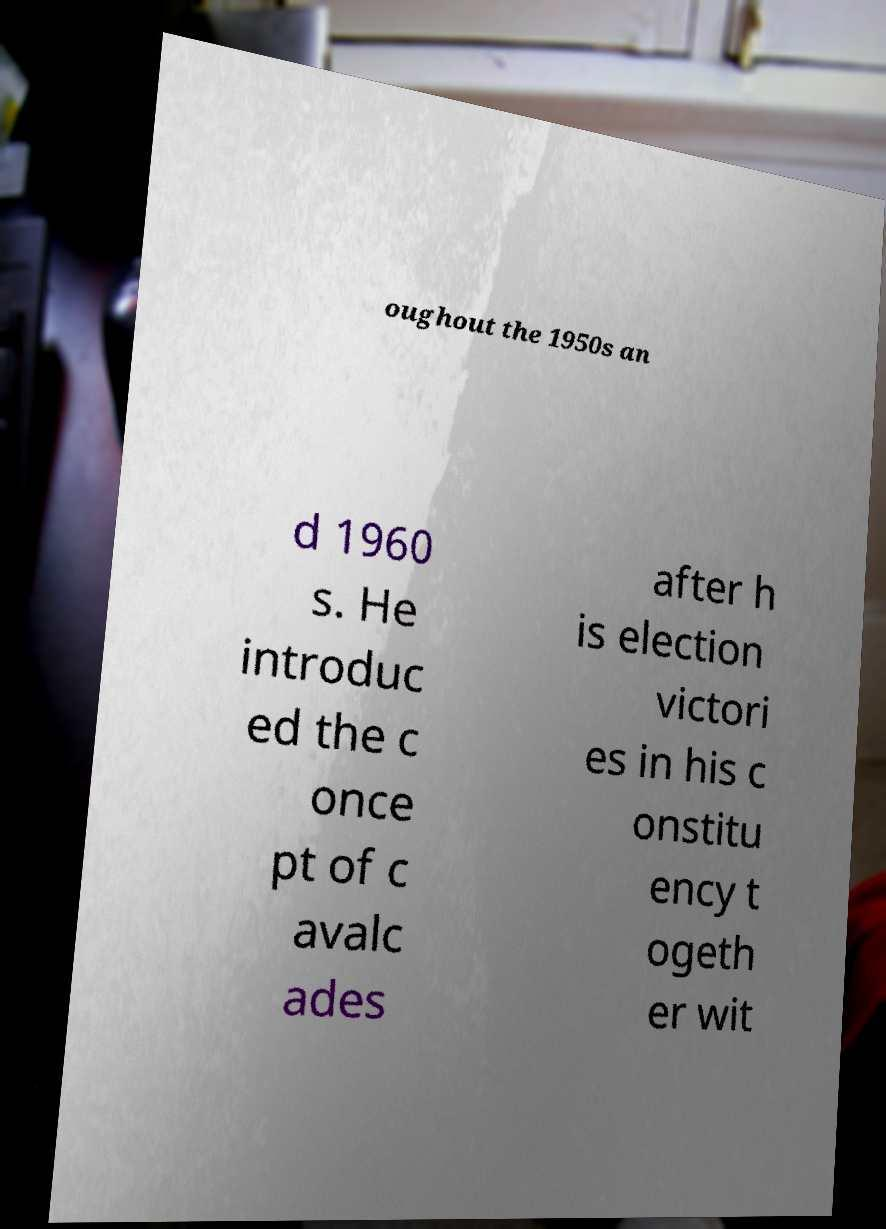Please read and relay the text visible in this image. What does it say? oughout the 1950s an d 1960 s. He introduc ed the c once pt of c avalc ades after h is election victori es in his c onstitu ency t ogeth er wit 